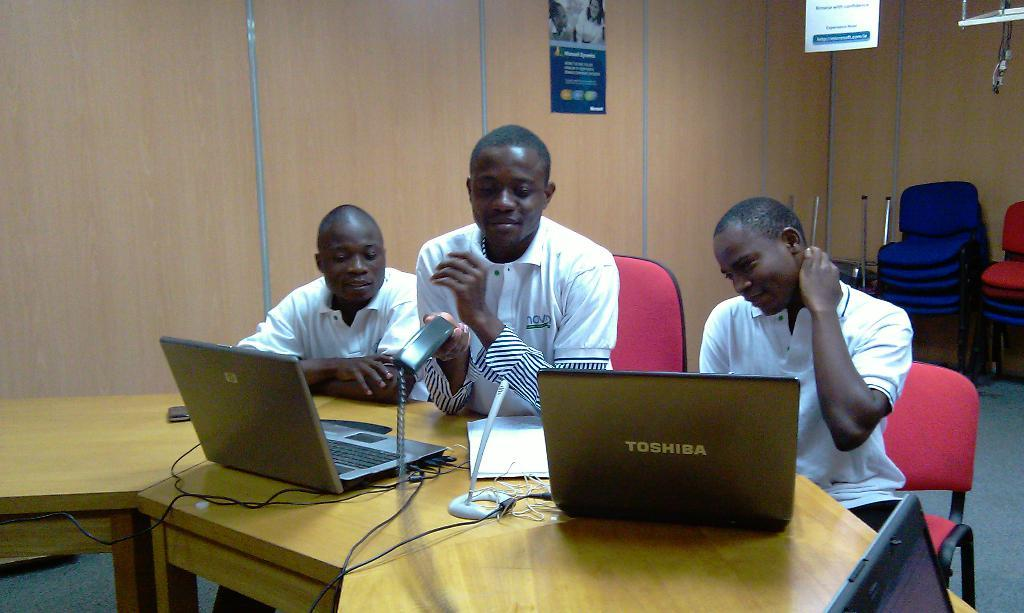How many people are in the image? There are three persons in the image. What are the persons doing in the image? The persons are sitting on chairs. What is on the table in the image? There are laptops on the table. What part of the room can be seen in the image? The floor is visible in the image. What is visible in the background of the image? There is a wall in the background of the image. What is the date of birth of the person sitting on the left chair in the image? There is no information about the date of birth of the persons in the image. In which direction is the north located in the image? The image does not provide any information about the direction of north. 